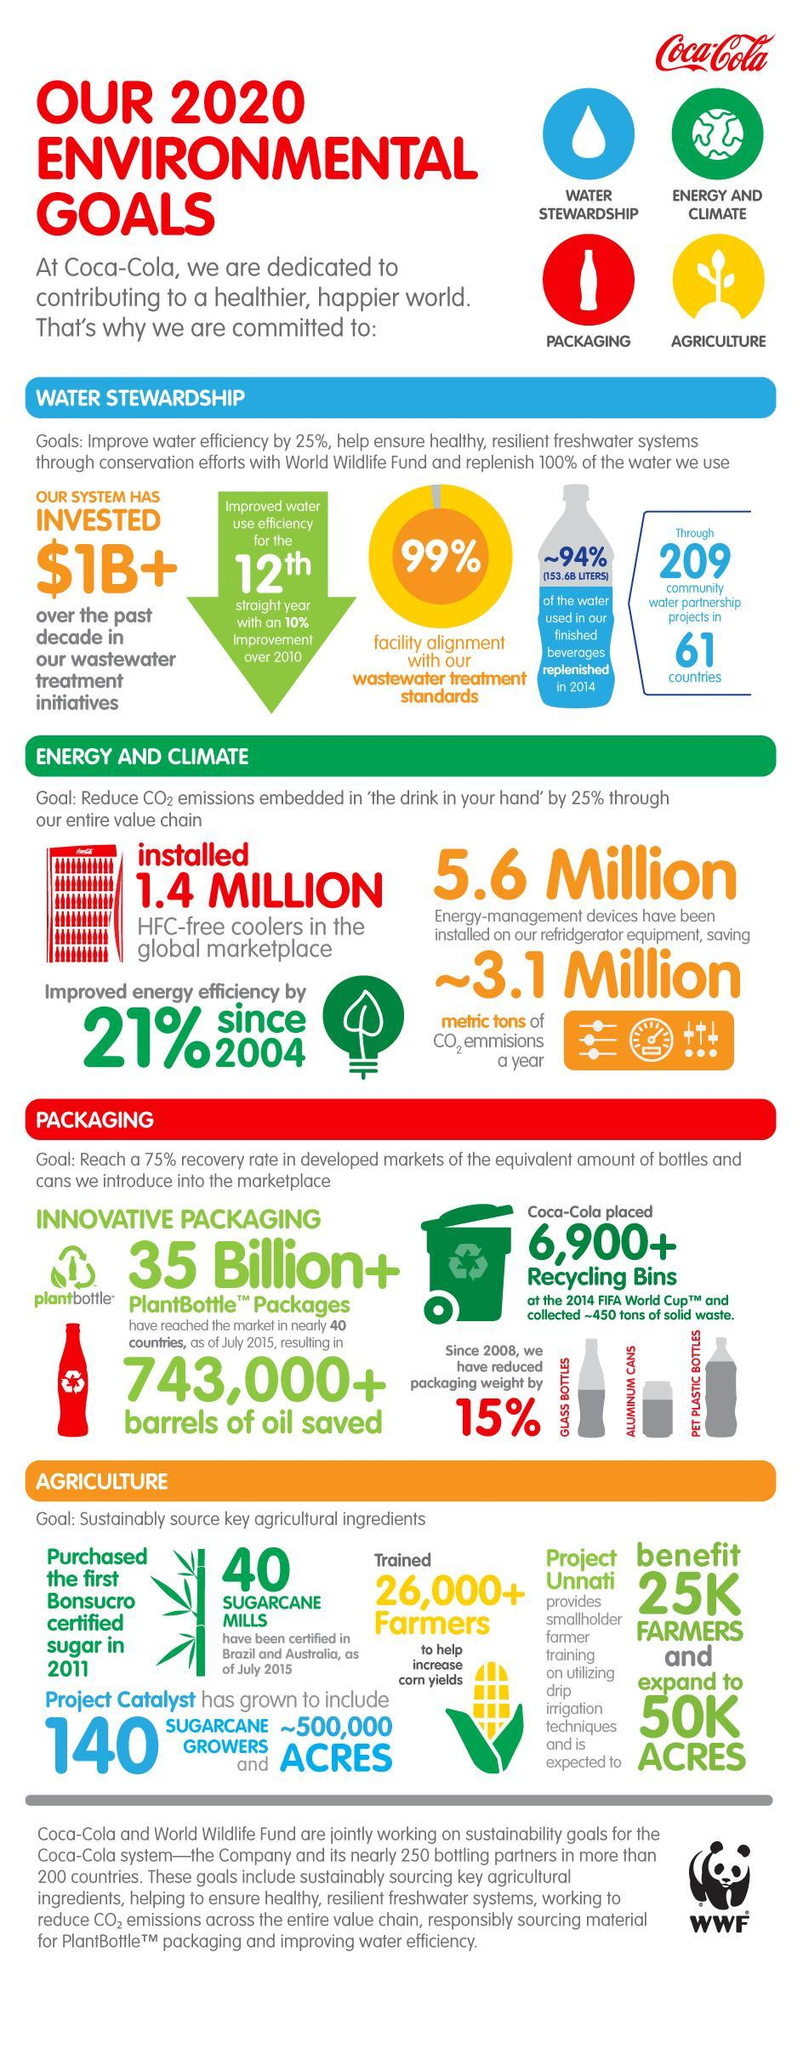How many sugar cane mills have been certified in Australia and Brazil?
Answer the question with a short phrase. 40 How many water partnership projects mentioned in this infographic? 209 